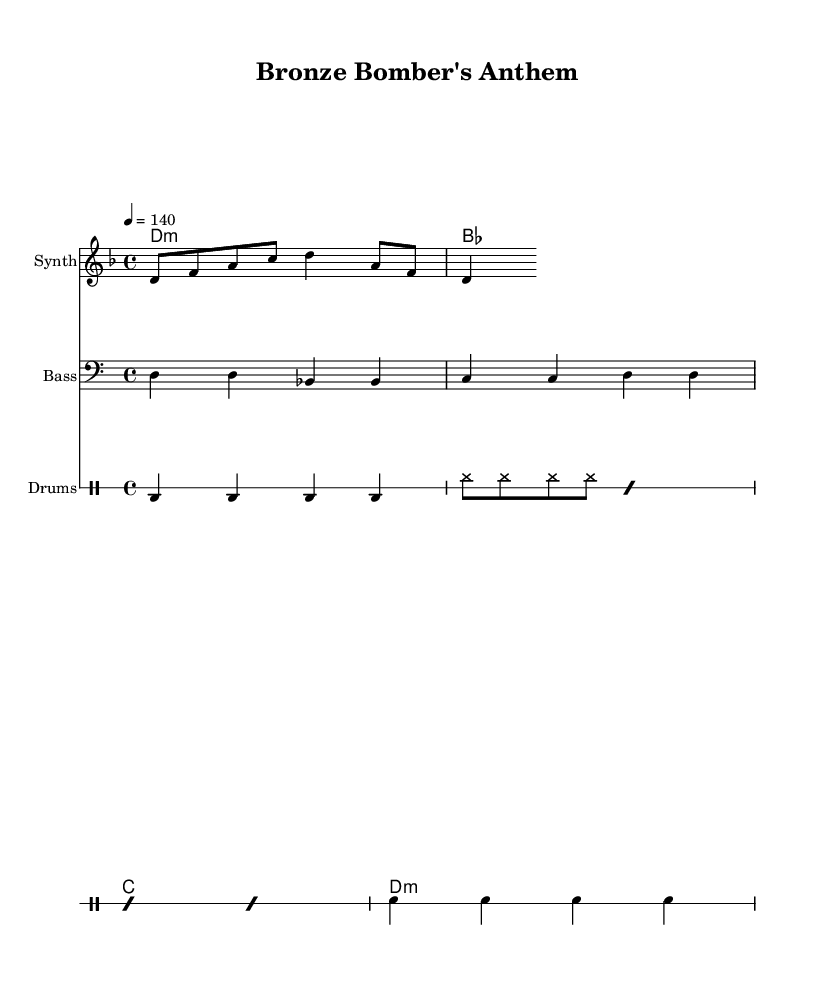What is the key signature of this music? The key signature is D minor, indicated by one flat (B flat) in the key signature area.
Answer: D minor What is the time signature of this music? The time signature is 4/4, which means there are four beats in each measure and the quarter note receives one beat.
Answer: 4/4 What is the tempo marking of this music? The tempo marking is 140 beats per minute, indicated by the marking "4 = 140" in the score.
Answer: 140 How many measures are in the melody? The melody, as presented, consists of two measures, as evidenced by the grouping of notes, with each measure containing four beats in total.
Answer: 2 What type of drum patterns are used here? The drum patterns include a bass drum, snare drum, and hi-hat, with specific rhythmic notations showing the structure of the drumline.
Answer: Bass, snare, hi-hat What is the main lyrical theme of the music? The main lyrical theme focuses on empowerment with the phrase "Bronze Bomber, power in his fists," reflecting a strong and motivating message.
Answer: Empowerment Which instrument is primarily featured in the melody? The melody primarily features a synthesizer, indicated by the instrument name listed in the staff header.
Answer: Synth 